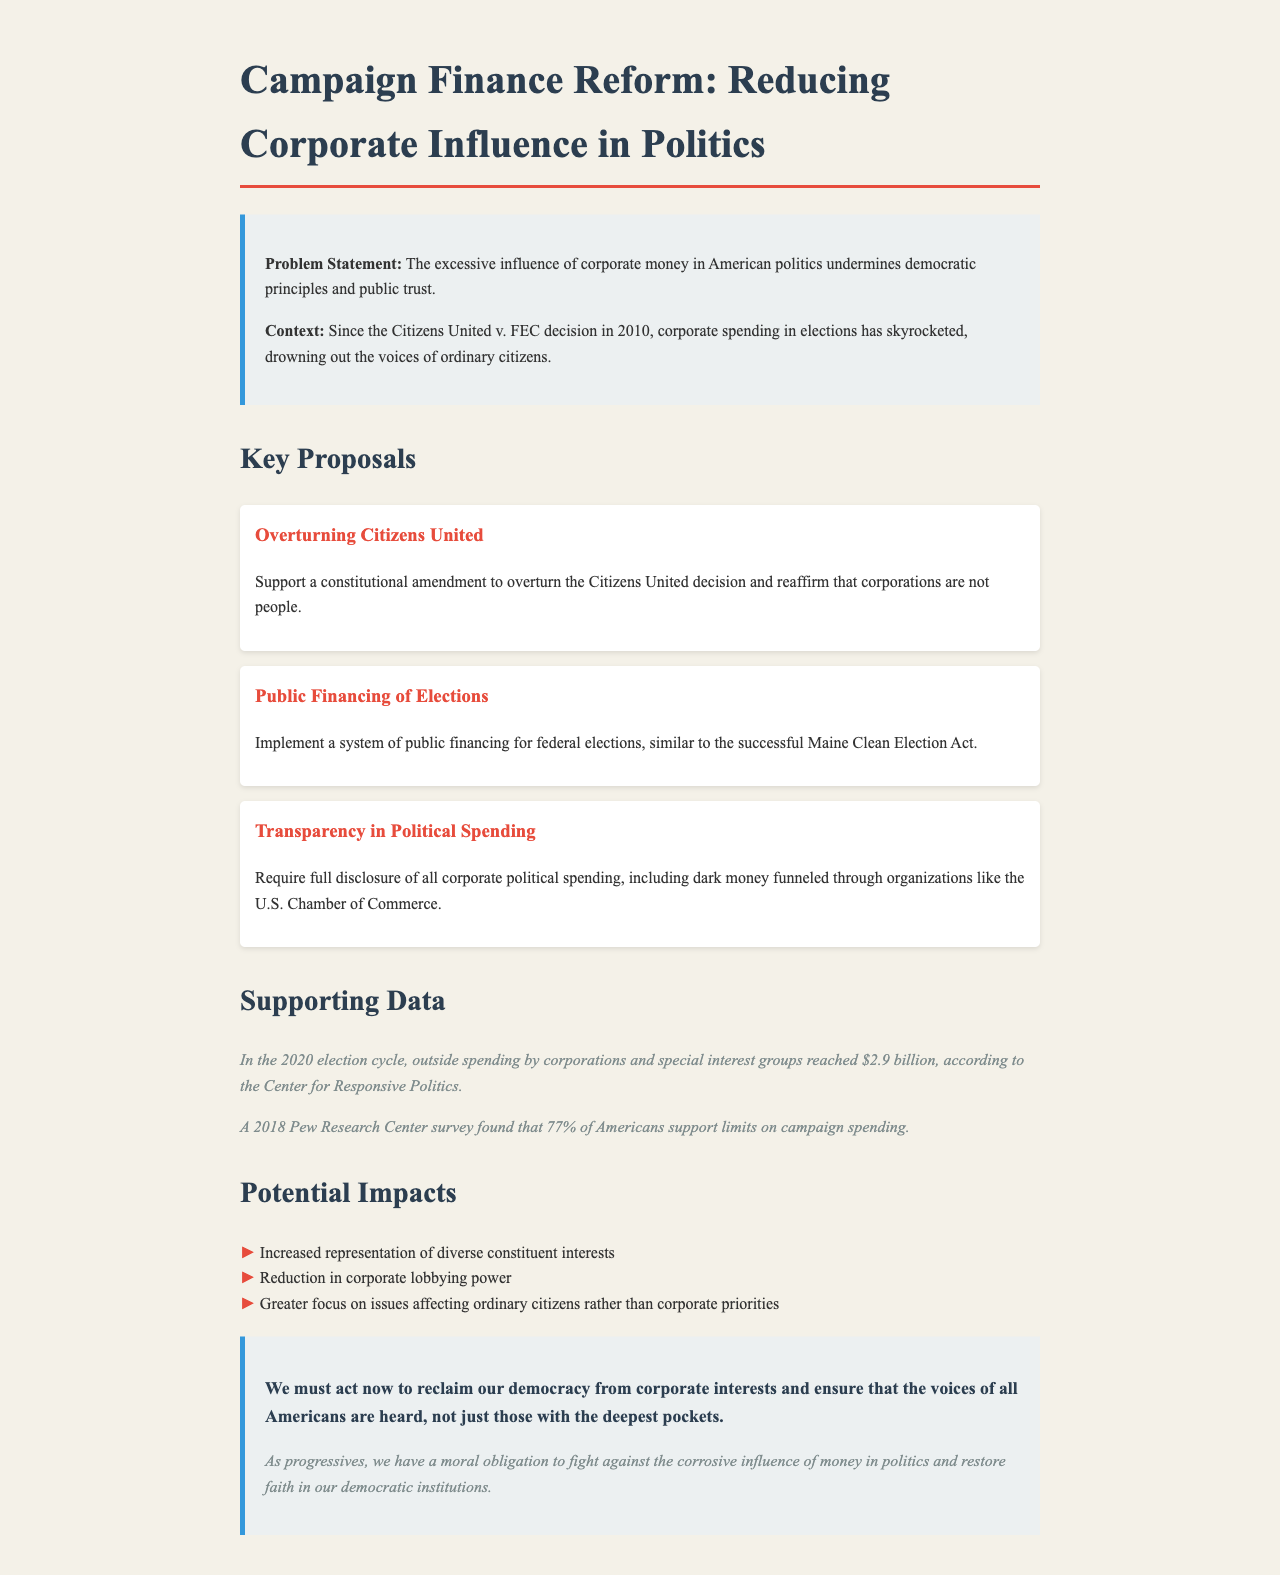What is the problem statement related to campaign finance reform? The problem statement highlights that the excessive influence of corporate money in American politics undermines democratic principles and public trust.
Answer: Excessive influence of corporate money in American politics What year was the Citizens United v. FEC decision made? The context of the document refers to the Citizens United v. FEC decision, which occurred in the year 2010.
Answer: 2010 How much outside spending did corporations and special interest groups reach in the 2020 election cycle? The supporting data states that outside spending by corporations and special interest groups amounted to $2.9 billion in the 2020 election cycle.
Answer: $2.9 billion What percentage of Americans support limits on campaign spending according to a 2018 Pew Research Center survey? The supporting data reveals that 77% of Americans support limits on campaign spending according to the survey.
Answer: 77% What is one of the potential impacts of campaign finance reform mentioned in the document? The document lists increased representation of diverse constituent interests as one of the potential impacts of campaign finance reform.
Answer: Increased representation of diverse constituent interests What is the proposed amendment aimed at overturning? The key proposal mentions a constitutional amendment to overturn the Citizens United decision.
Answer: Citizens United What does the call to action emphasize regarding democracy? The call to action emphasizes the need to reclaim democracy from corporate interests and ensure all voices are heard.
Answer: Reclaim our democracy from corporate interests 